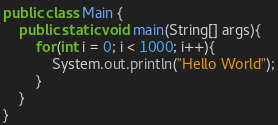<code> <loc_0><loc_0><loc_500><loc_500><_Java_>
public class Main {
	public static void main(String[] args){
		for(int i = 0; i < 1000; i++){
			System.out.println("Hello World");
		}
	}
}</code> 